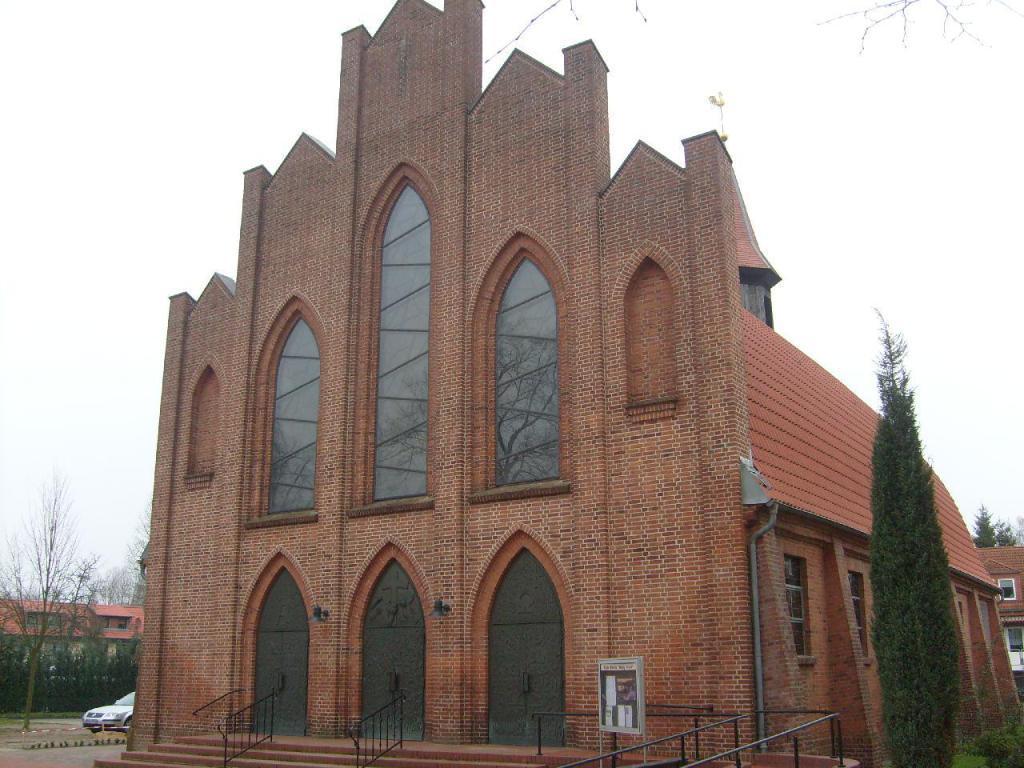Can you describe this image briefly? This picture is taken outside the building. At the right side there is a tree. In the center there is a building with the glass windows on it. There are metal fencing and some sign board. At the left side a car is running on the road. There are some trees at the left side and red colour roof top building. In the background there is a sky and red colour roof top building with some trees visible in the background. 